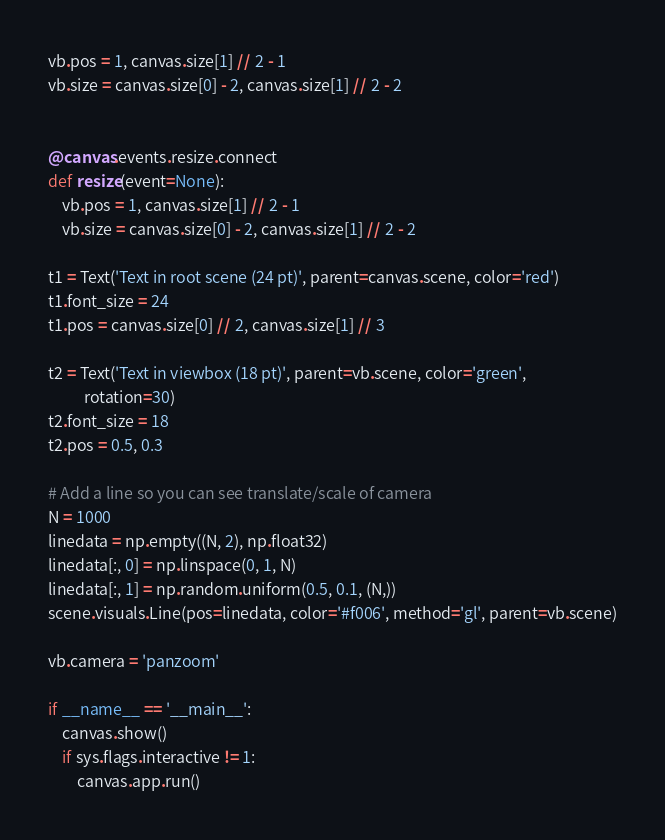Convert code to text. <code><loc_0><loc_0><loc_500><loc_500><_Python_>
vb.pos = 1, canvas.size[1] // 2 - 1
vb.size = canvas.size[0] - 2, canvas.size[1] // 2 - 2


@canvas.events.resize.connect
def resize(event=None):
    vb.pos = 1, canvas.size[1] // 2 - 1
    vb.size = canvas.size[0] - 2, canvas.size[1] // 2 - 2

t1 = Text('Text in root scene (24 pt)', parent=canvas.scene, color='red')
t1.font_size = 24
t1.pos = canvas.size[0] // 2, canvas.size[1] // 3

t2 = Text('Text in viewbox (18 pt)', parent=vb.scene, color='green',
          rotation=30)
t2.font_size = 18
t2.pos = 0.5, 0.3

# Add a line so you can see translate/scale of camera
N = 1000
linedata = np.empty((N, 2), np.float32)
linedata[:, 0] = np.linspace(0, 1, N)
linedata[:, 1] = np.random.uniform(0.5, 0.1, (N,))
scene.visuals.Line(pos=linedata, color='#f006', method='gl', parent=vb.scene)

vb.camera = 'panzoom'

if __name__ == '__main__':
    canvas.show()
    if sys.flags.interactive != 1:
        canvas.app.run()
</code> 